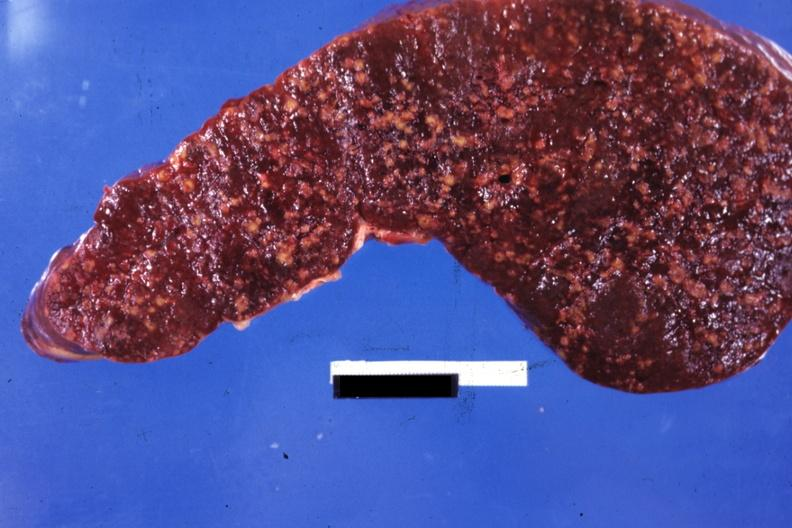where is this part in?
Answer the question using a single word or phrase. Spleen 